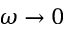<formula> <loc_0><loc_0><loc_500><loc_500>\omega \to 0</formula> 